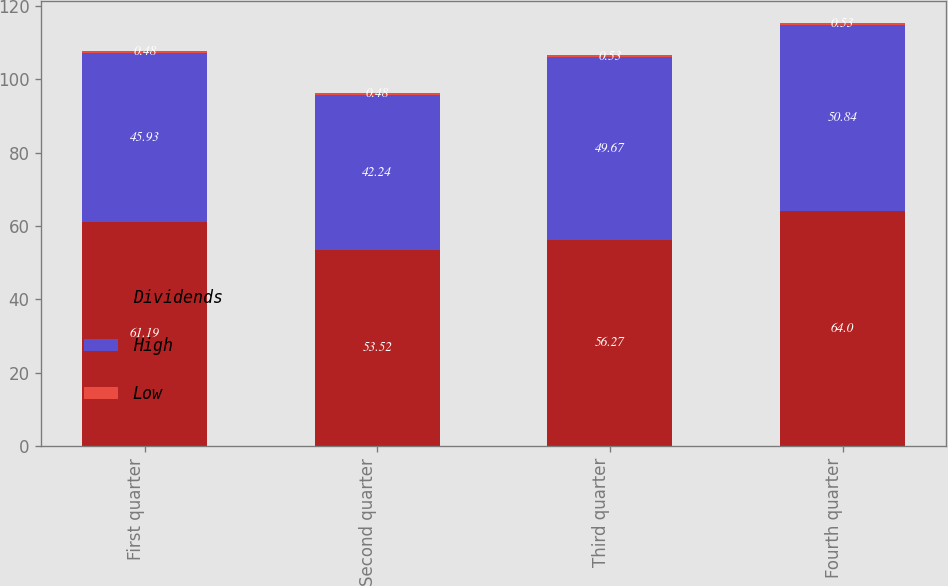<chart> <loc_0><loc_0><loc_500><loc_500><stacked_bar_chart><ecel><fcel>First quarter<fcel>Second quarter<fcel>Third quarter<fcel>Fourth quarter<nl><fcel>Dividends<fcel>61.19<fcel>53.52<fcel>56.27<fcel>64<nl><fcel>High<fcel>45.93<fcel>42.24<fcel>49.67<fcel>50.84<nl><fcel>Low<fcel>0.48<fcel>0.48<fcel>0.53<fcel>0.53<nl></chart> 